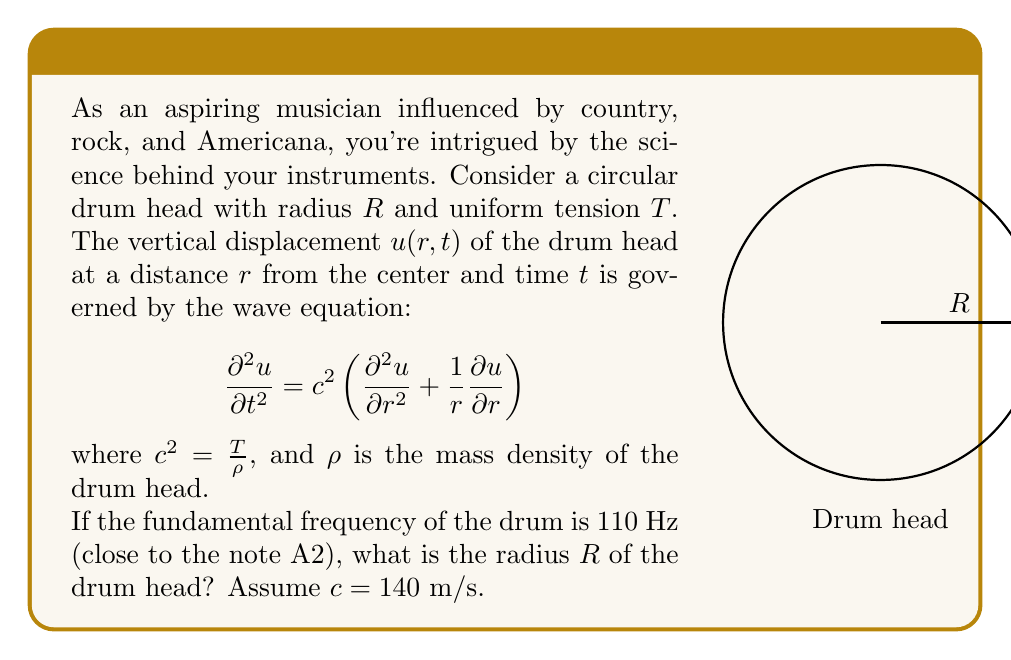Can you answer this question? Let's approach this step-by-step:

1) The fundamental frequency of a circular membrane is given by:

   $$f = \frac{\alpha_{01}c}{2\pi R}$$

   where $\alpha_{01} \approx 2.4048$ is the first zero of the Bessel function of the first kind.

2) We're given that $f = 110$ Hz and $c = 140$ m/s. Let's substitute these values:

   $$110 = \frac{2.4048 \cdot 140}{2\pi R}$$

3) Now, let's solve for $R$:

   $$R = \frac{2.4048 \cdot 140}{2\pi \cdot 110}$$

4) Let's calculate this:

   $$R = \frac{336.672}{691.15} \approx 0.4871 \text{ m}$$

5) Rounding to three significant figures:

   $$R \approx 0.487 \text{ m}$$

This radius corresponds to a drum diameter of about 0.974 m or 38.3 inches, which is close to the size of a typical bass drum used in country and rock music.
Answer: $R \approx 0.487 \text{ m}$ 